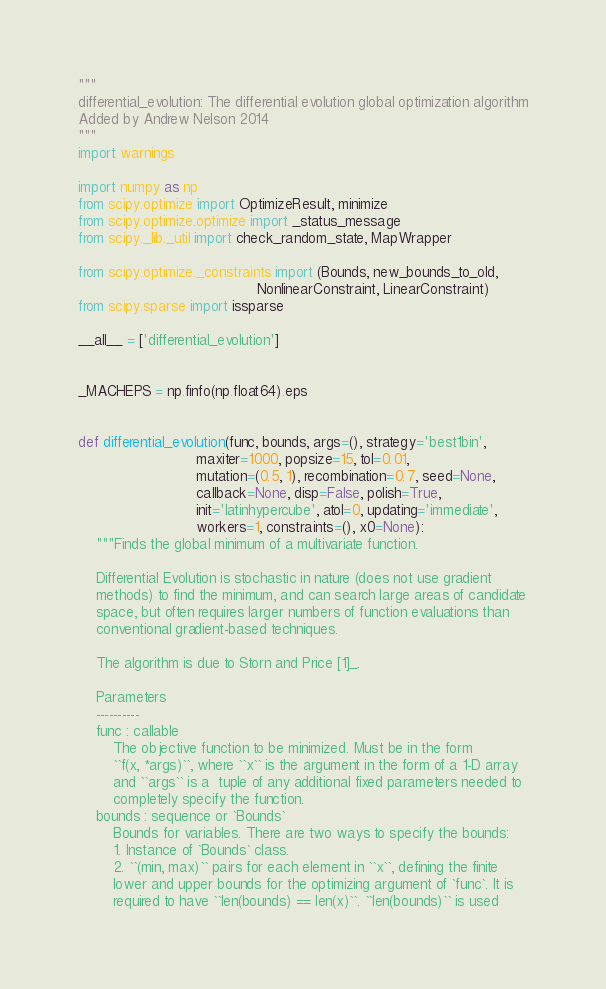<code> <loc_0><loc_0><loc_500><loc_500><_Python_>"""
differential_evolution: The differential evolution global optimization algorithm
Added by Andrew Nelson 2014
"""
import warnings

import numpy as np
from scipy.optimize import OptimizeResult, minimize
from scipy.optimize.optimize import _status_message
from scipy._lib._util import check_random_state, MapWrapper

from scipy.optimize._constraints import (Bounds, new_bounds_to_old,
                                         NonlinearConstraint, LinearConstraint)
from scipy.sparse import issparse

__all__ = ['differential_evolution']


_MACHEPS = np.finfo(np.float64).eps


def differential_evolution(func, bounds, args=(), strategy='best1bin',
                           maxiter=1000, popsize=15, tol=0.01,
                           mutation=(0.5, 1), recombination=0.7, seed=None,
                           callback=None, disp=False, polish=True,
                           init='latinhypercube', atol=0, updating='immediate',
                           workers=1, constraints=(), x0=None):
    """Finds the global minimum of a multivariate function.

    Differential Evolution is stochastic in nature (does not use gradient
    methods) to find the minimum, and can search large areas of candidate
    space, but often requires larger numbers of function evaluations than
    conventional gradient-based techniques.

    The algorithm is due to Storn and Price [1]_.

    Parameters
    ----------
    func : callable
        The objective function to be minimized. Must be in the form
        ``f(x, *args)``, where ``x`` is the argument in the form of a 1-D array
        and ``args`` is a  tuple of any additional fixed parameters needed to
        completely specify the function.
    bounds : sequence or `Bounds`
        Bounds for variables. There are two ways to specify the bounds:
        1. Instance of `Bounds` class.
        2. ``(min, max)`` pairs for each element in ``x``, defining the finite
        lower and upper bounds for the optimizing argument of `func`. It is
        required to have ``len(bounds) == len(x)``. ``len(bounds)`` is used</code> 